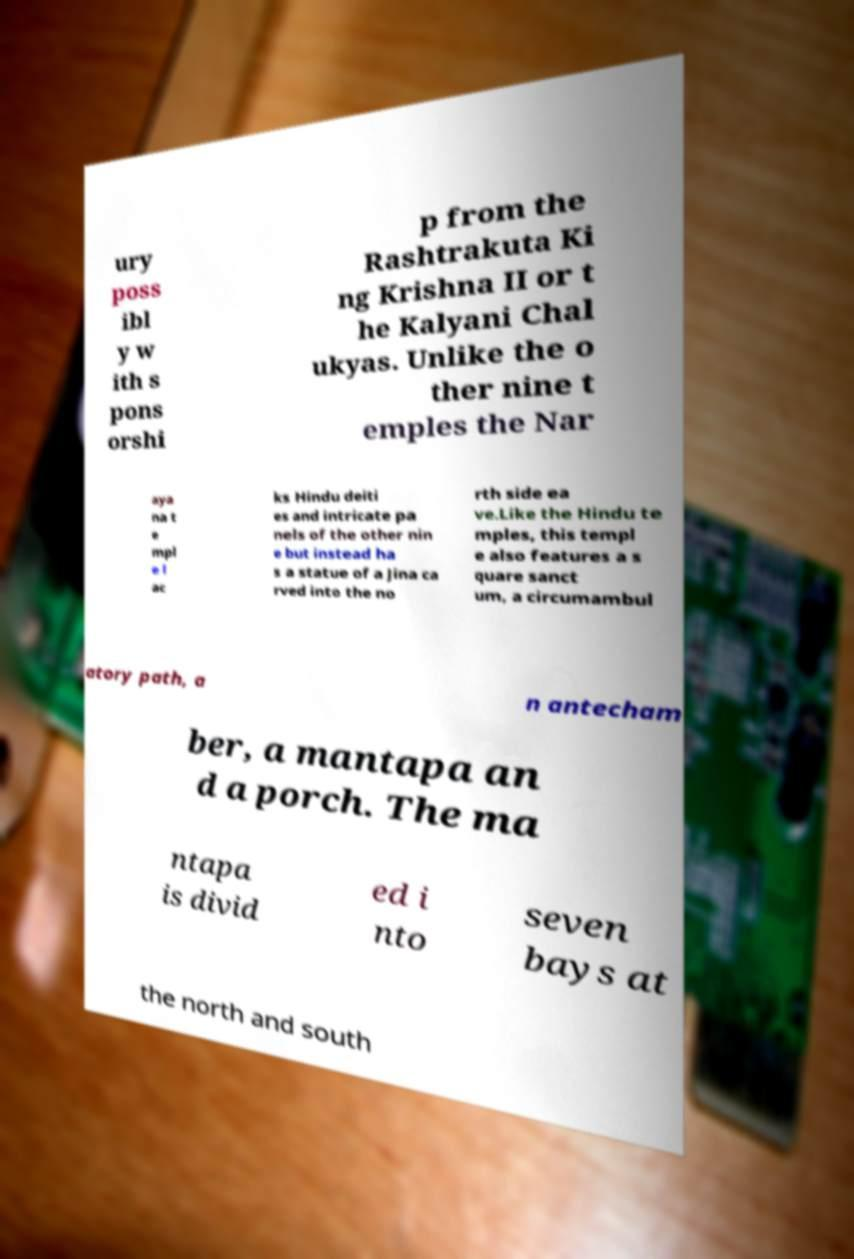For documentation purposes, I need the text within this image transcribed. Could you provide that? ury poss ibl y w ith s pons orshi p from the Rashtrakuta Ki ng Krishna II or t he Kalyani Chal ukyas. Unlike the o ther nine t emples the Nar aya na t e mpl e l ac ks Hindu deiti es and intricate pa nels of the other nin e but instead ha s a statue of a Jina ca rved into the no rth side ea ve.Like the Hindu te mples, this templ e also features a s quare sanct um, a circumambul atory path, a n antecham ber, a mantapa an d a porch. The ma ntapa is divid ed i nto seven bays at the north and south 